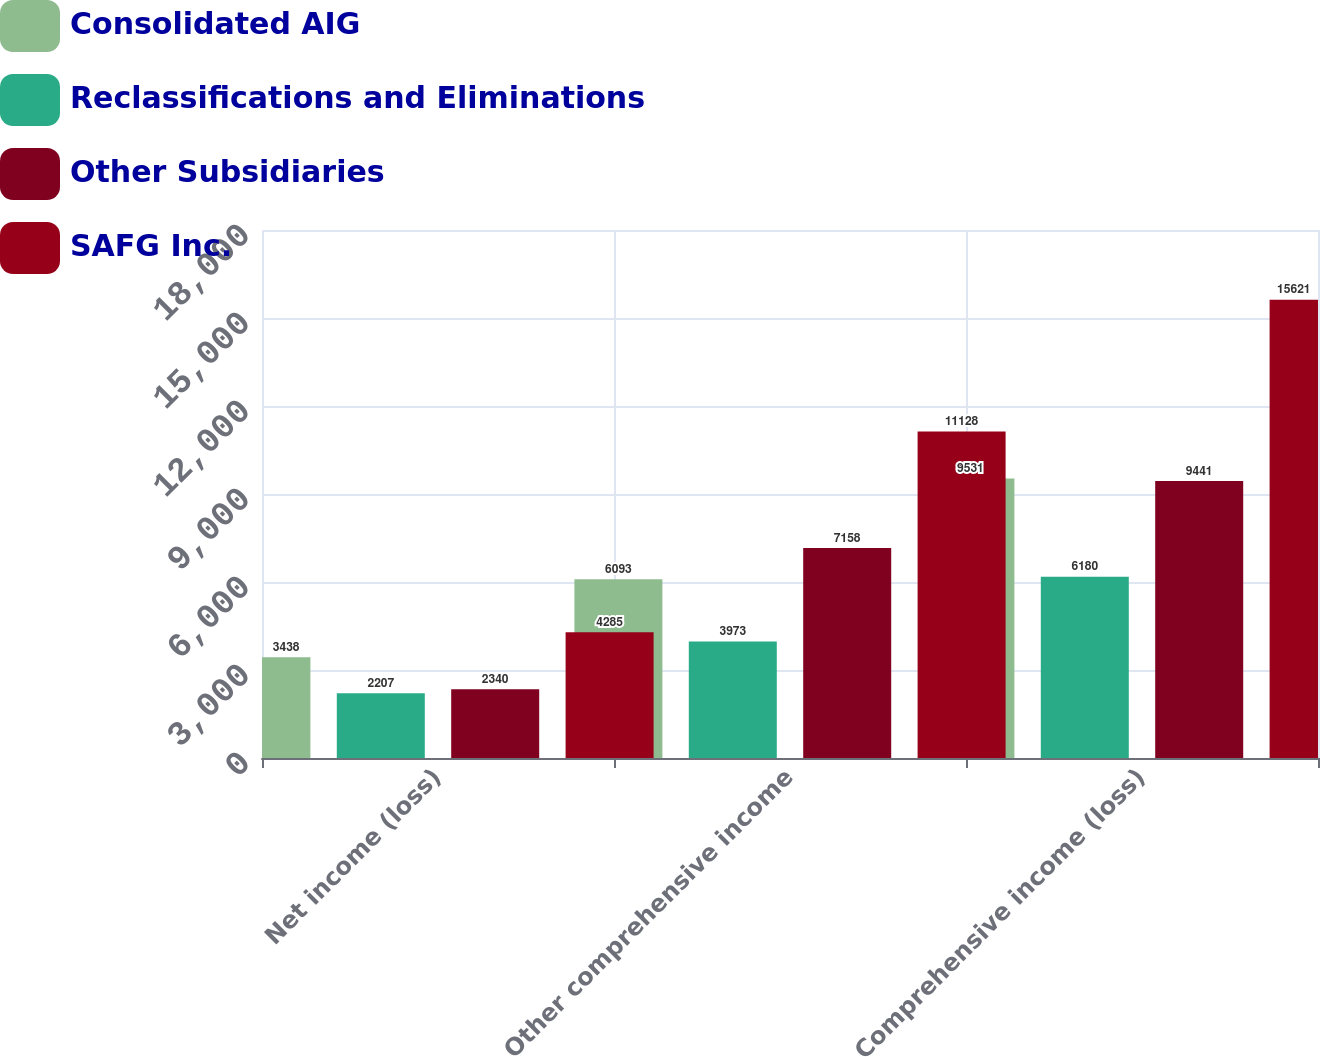<chart> <loc_0><loc_0><loc_500><loc_500><stacked_bar_chart><ecel><fcel>Net income (loss)<fcel>Other comprehensive income<fcel>Comprehensive income (loss)<nl><fcel>Consolidated AIG<fcel>3438<fcel>6093<fcel>9531<nl><fcel>Reclassifications and Eliminations<fcel>2207<fcel>3973<fcel>6180<nl><fcel>Other Subsidiaries<fcel>2340<fcel>7158<fcel>9441<nl><fcel>SAFG Inc.<fcel>4285<fcel>11128<fcel>15621<nl></chart> 